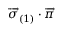Convert formula to latex. <formula><loc_0><loc_0><loc_500><loc_500>\overrightarrow { \sigma } _ { \left ( 1 \right ) } \cdot \overrightarrow { \pi }</formula> 